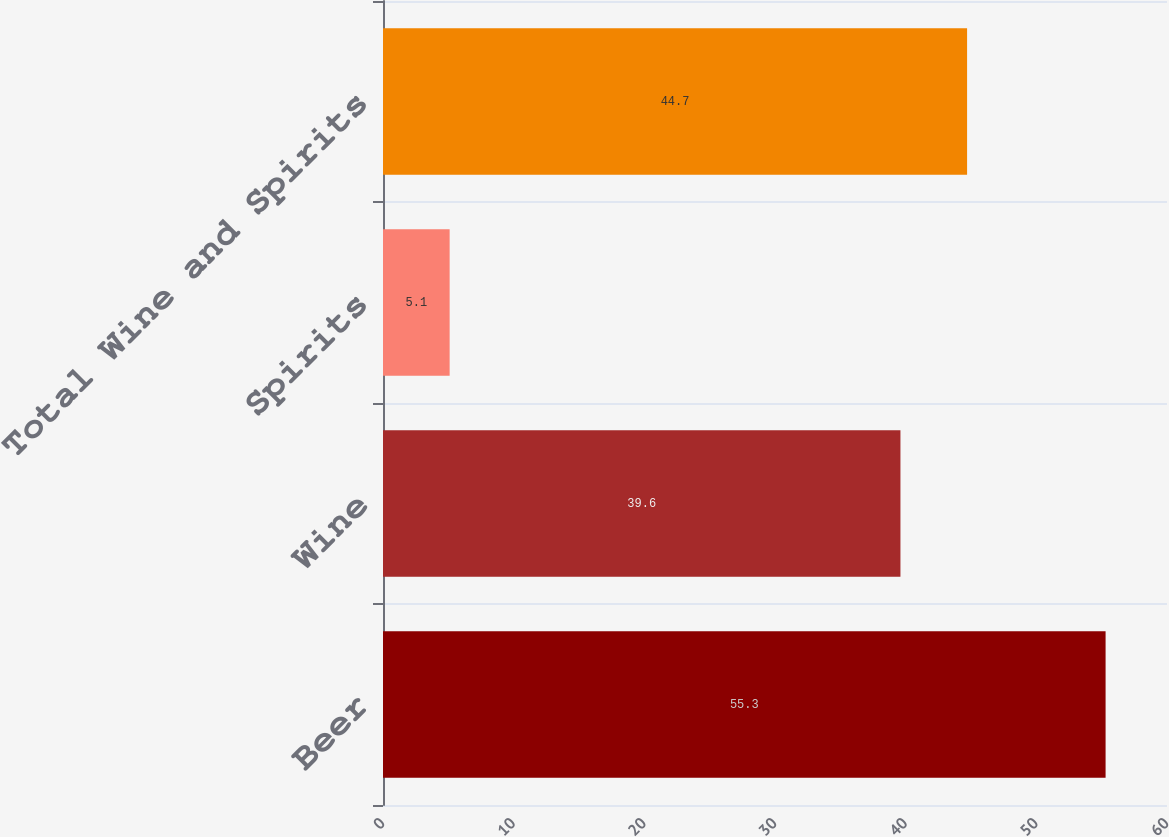Convert chart to OTSL. <chart><loc_0><loc_0><loc_500><loc_500><bar_chart><fcel>Beer<fcel>Wine<fcel>Spirits<fcel>Total Wine and Spirits<nl><fcel>55.3<fcel>39.6<fcel>5.1<fcel>44.7<nl></chart> 